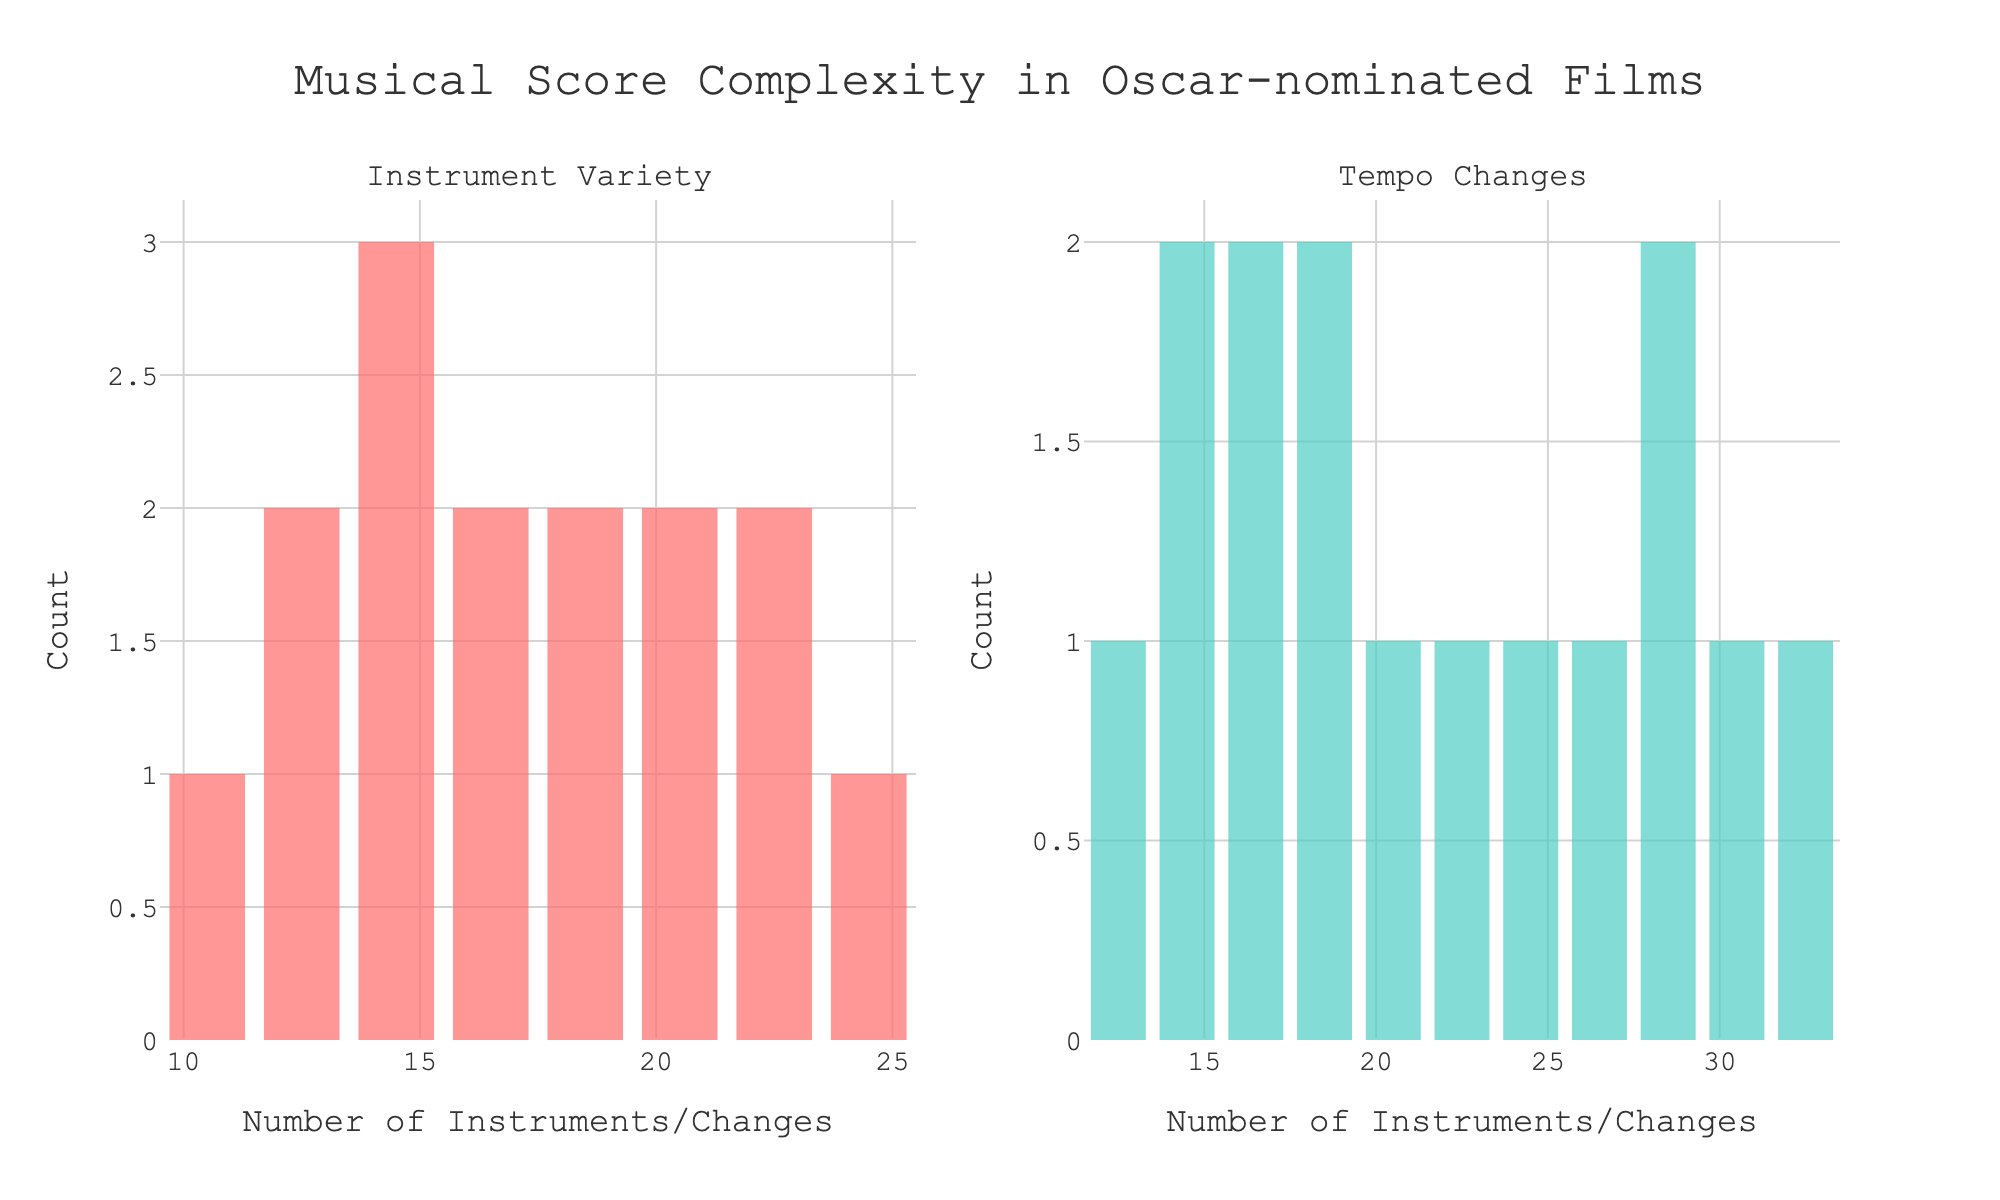What is the title of the figure? The title of the figure is displayed prominently at the top of the plot. It reads "Musical Score Complexity in Oscar-nominated Films".
Answer: Musical Score Complexity in Oscar-nominated Films Which color represents the histogram for Instrument Variety? The color of the histogram for Instrument Variety is noticeably different from the other histogram. The Instrument Variety histogram is colored in a shade of red.
Answer: Red How many subplots are there in the figure? By counting the separate plot areas, we can see that there are two subplots in the figure.
Answer: Two What is the total count of films that have Instrument Variety between 15 and 20? By looking at the histogram for Instrument Variety, we can count the bars that fall within the range 15 to 20. The counts are 2 for 15, 1 for 16, 0 for 17-18, 2 for 19, making a total of 5.
Answer: 5 Which histogram shows a higher peak value? Observing the highest bars in both histograms, the histogram for Tempo Changes shows a higher peak value compared to Instrument Variety.
Answer: Tempo Changes What is the range of Tempo Changes that appears to have the most entries? By looking at the histogram for Tempo Changes and identifying the tallest bar, we can see the range with the highest frequency. The tallest bar is located around 28-32 changes.
Answer: 28-32 changes Compare the average Instrument Variety to the average Tempo Changes across the films. To find the averages, we sum the Instrument Variety values and divide by the number of films, then do the same for Tempo Changes. Instrument Variety: (18+12+22+15+25+14+16+20+13+11+23+17+19+21+15)/15 = 17.13; Tempo Changes: (24+32+19+14+28+17+22+15+18+26+21+29+31+16+13)/15 = 21.07. The average Tempo Changes is higher.
Answer: Tempo Changes Which subplot displays a wider distribution of values? By comparing the spread of the bars in the two subplots, the Tempo Changes histogram shows a wider distribution as it covers a larger range of values from around 13 to 32, whereas Instrument Variety ranges from about 11 to 25.
Answer: Tempo Changes 